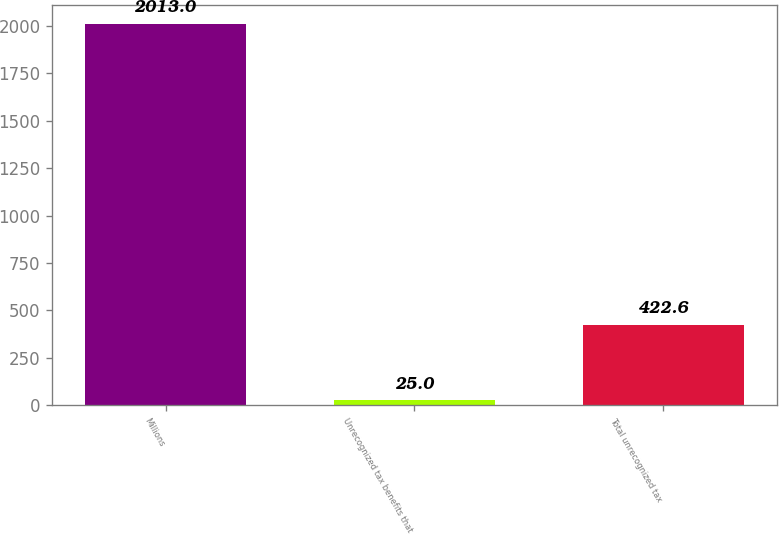Convert chart. <chart><loc_0><loc_0><loc_500><loc_500><bar_chart><fcel>Millions<fcel>Unrecognized tax benefits that<fcel>Total unrecognized tax<nl><fcel>2013<fcel>25<fcel>422.6<nl></chart> 